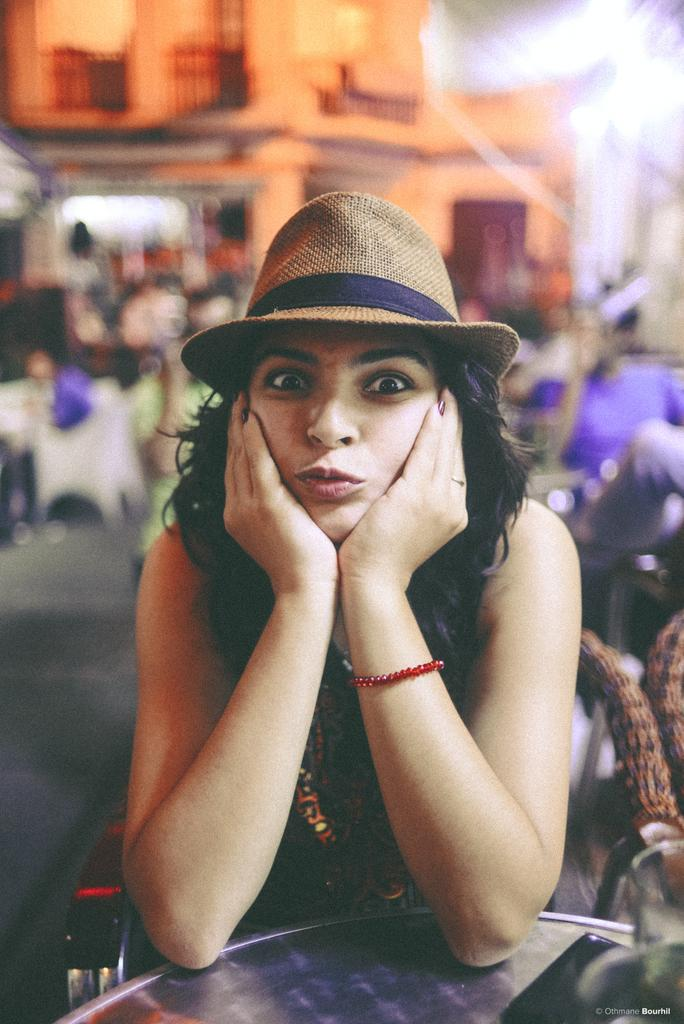Who is the main subject in the image? There is a woman in the image. What is the woman doing in the image? The woman is sitting on a chair and posing for the picture. What is the woman's position relative to the table? The woman is in front of a table. How many chairs are visible in the image? There is one chair on the right side of the image. What can be said about the background of the image? The background of the image is blurred. What type of hand gesture is the woman making in the image? There is no hand gesture visible in the image, as the woman's hands are not shown. 